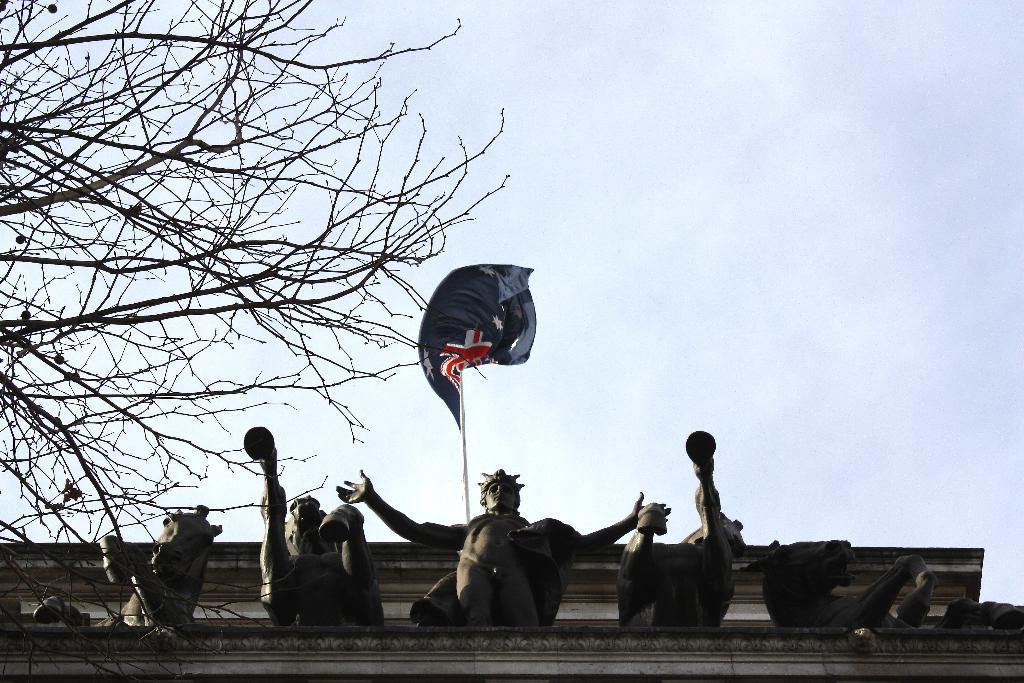Describe this image in one or two sentences. In this picture I can see there is a building, there are statues, flag pole, flag and the sky is clear. 